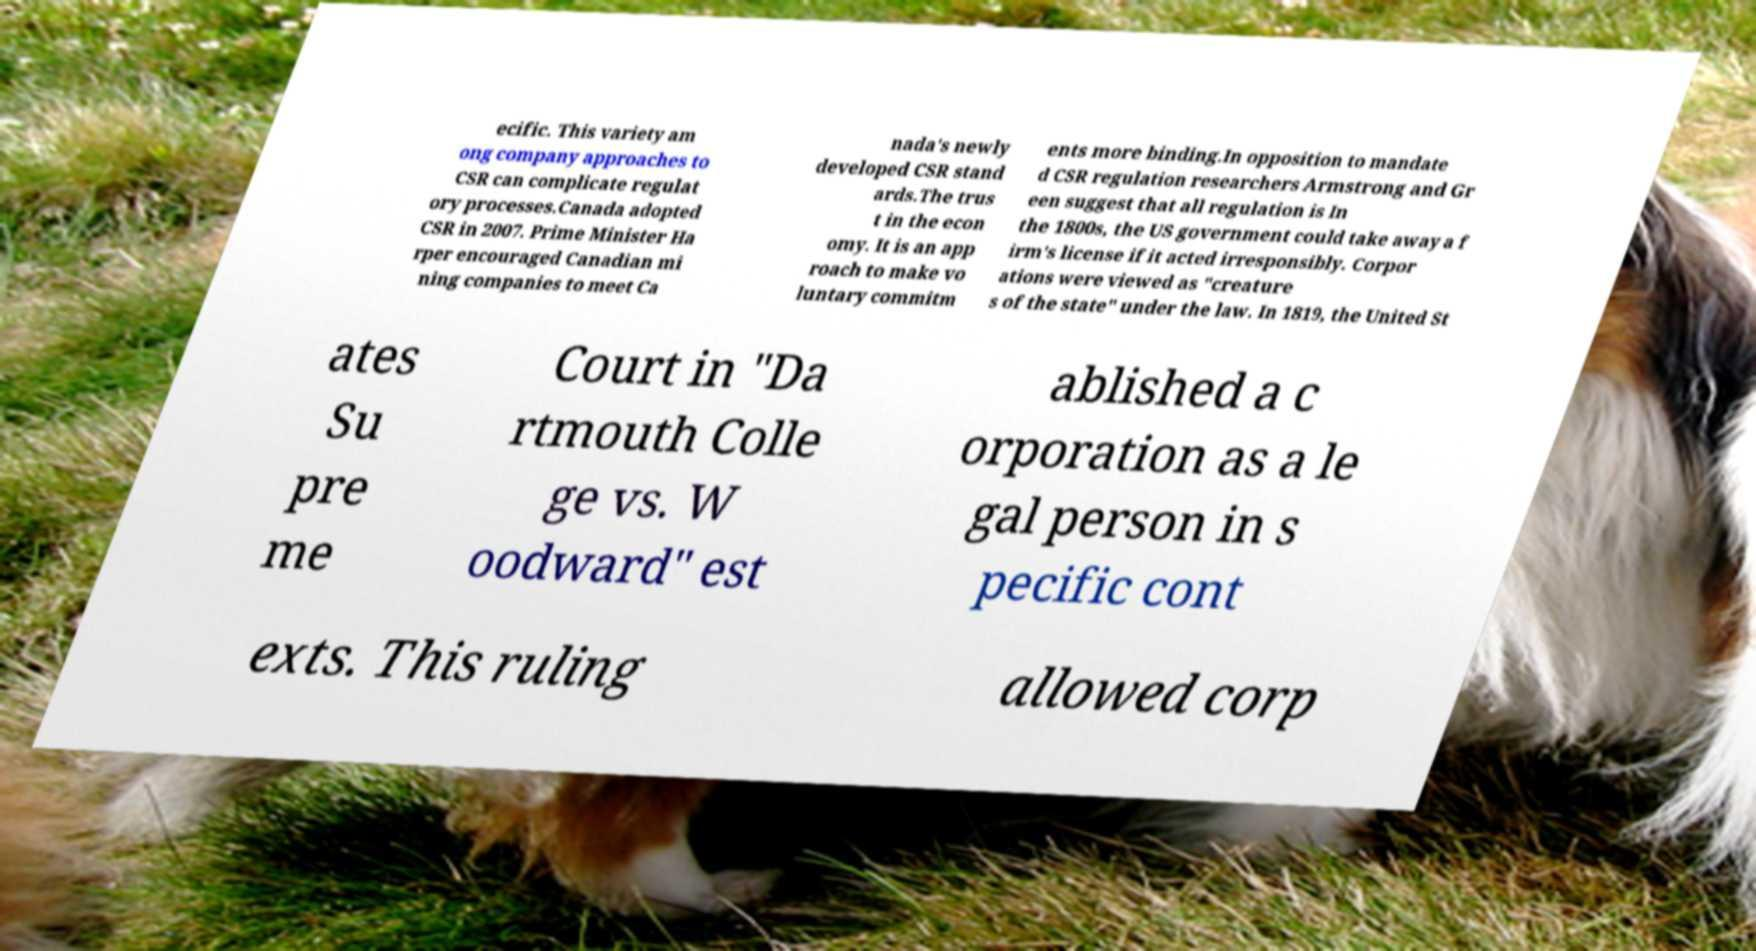For documentation purposes, I need the text within this image transcribed. Could you provide that? ecific. This variety am ong company approaches to CSR can complicate regulat ory processes.Canada adopted CSR in 2007. Prime Minister Ha rper encouraged Canadian mi ning companies to meet Ca nada's newly developed CSR stand ards.The trus t in the econ omy. It is an app roach to make vo luntary commitm ents more binding.In opposition to mandate d CSR regulation researchers Armstrong and Gr een suggest that all regulation is In the 1800s, the US government could take away a f irm's license if it acted irresponsibly. Corpor ations were viewed as "creature s of the state" under the law. In 1819, the United St ates Su pre me Court in "Da rtmouth Colle ge vs. W oodward" est ablished a c orporation as a le gal person in s pecific cont exts. This ruling allowed corp 